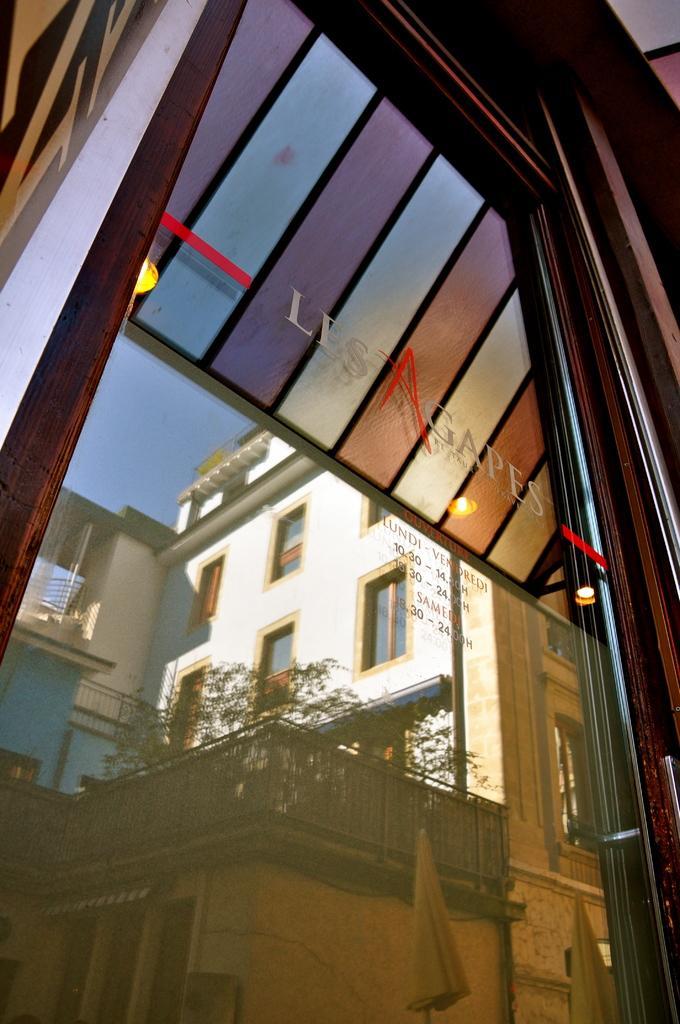Please provide a concise description of this image. In this image, we can see a door with some glass and text. We can also see a building, a few plants, the fence, the sky and some objects from the glass. 